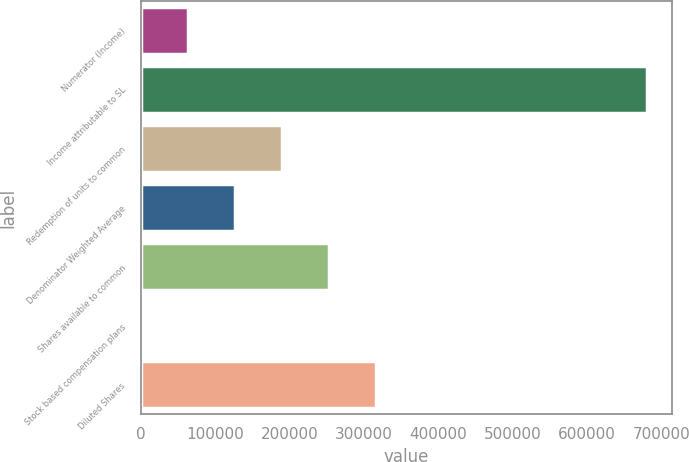Convert chart. <chart><loc_0><loc_0><loc_500><loc_500><bar_chart><fcel>Numerator (Income)<fcel>Income attributable to SL<fcel>Redemption of units to common<fcel>Denominator Weighted Average<fcel>Shares available to common<fcel>Stock based compensation plans<fcel>Diluted Shares<nl><fcel>63633.4<fcel>680368<fcel>189906<fcel>126770<fcel>253043<fcel>497<fcel>316179<nl></chart> 